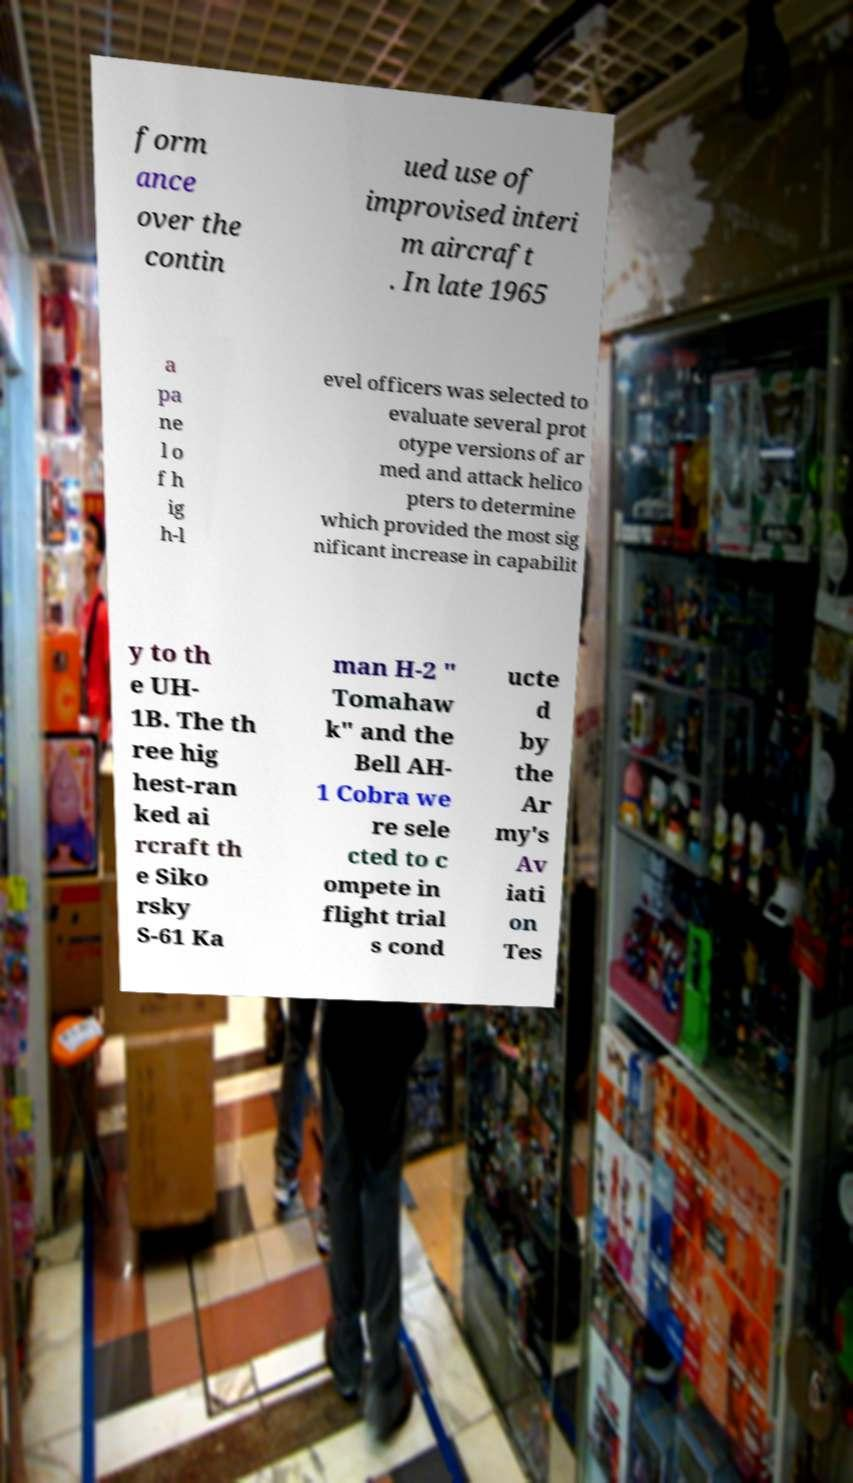Please identify and transcribe the text found in this image. form ance over the contin ued use of improvised interi m aircraft . In late 1965 a pa ne l o f h ig h-l evel officers was selected to evaluate several prot otype versions of ar med and attack helico pters to determine which provided the most sig nificant increase in capabilit y to th e UH- 1B. The th ree hig hest-ran ked ai rcraft th e Siko rsky S-61 Ka man H-2 " Tomahaw k" and the Bell AH- 1 Cobra we re sele cted to c ompete in flight trial s cond ucte d by the Ar my's Av iati on Tes 